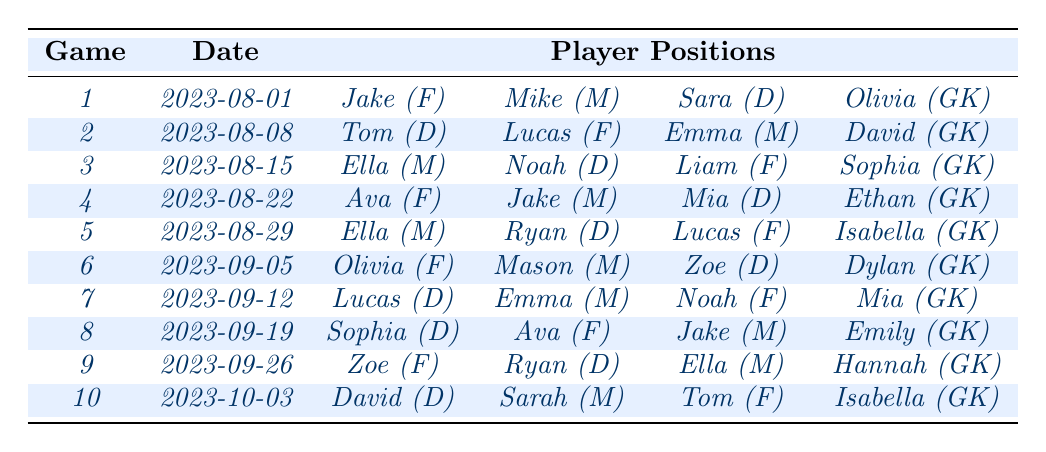What position did Jake play in game 1? In game 1, the table shows that Jake played as a Forward (F).
Answer: Forward How many times did Lucas play as a Defender? Lucas played as a Defender in games 2, 5, and 10. That's a total of 3 times.
Answer: 3 times Which player appeared as a Goalkeeper most frequently? The table shows that Isabella and David each played as Goalkeeper in 2 games. Therefore, multiple players have the highest frequency, which is 2.
Answer: Multiple players (Isabella and David) - 2 times What is the average number of players per position in the last 10 games? There are 4 players per game across 10 games, totaling 40 player positions listed. Since 4 different positions (Forward, Midfielder, Defender, Goalkeeper) are played, the average number of players per position is 40 / 4 = 10.
Answer: 10 Did Mia play as a Forward in any of the games? According to the table, Mia did not play as a Forward in any games, only as a Defender and Goalkeeper.
Answer: No Which positions did Ella play in the last 10 games? Reviewing the data, Ella played as a Midfielder in games 3, 5, and 9, and did not play in any other position throughout the last 10 games.
Answer: Midfielder How many games featured Olivia in the Forward position? Olivia played as a Forward in game 6. Looking through the table, that is the only game with this position reported for her.
Answer: 1 game Who played in the Midfield position the most times? The data indicates that players Emma, Jake, Ella, and Ryan all played as Midfielders in multiple games; counting each occurrence shows Emma played 3 times, Jake 3 times, and Ryan 3 times, as well. Therefore, they are tied for the most appearances.
Answer: Emma, Jake, and Ryan - 3 times each What percentage of the games did Tom play as a Forward? Tom played as a Forward in games 2 and 10, which is 2 out of 10 games. Calculating the percentage gives (2 / 10) * 100 = 20%.
Answer: 20% How many players played as Defenders in game 5? The table indicates that two players, Ryan and Ben, played as Defenders in game 5.
Answer: 2 players Which player had the most varied positions throughout the games? Analyzing the table, it's determined that Jake played Forward, Midfielder, and in another game as Midfielder. He played 3 positions across the games, thus showcasing some positional versatility compared to others like Noah or Ryan who played mostly in one position.
Answer: Jake - 3 positions 